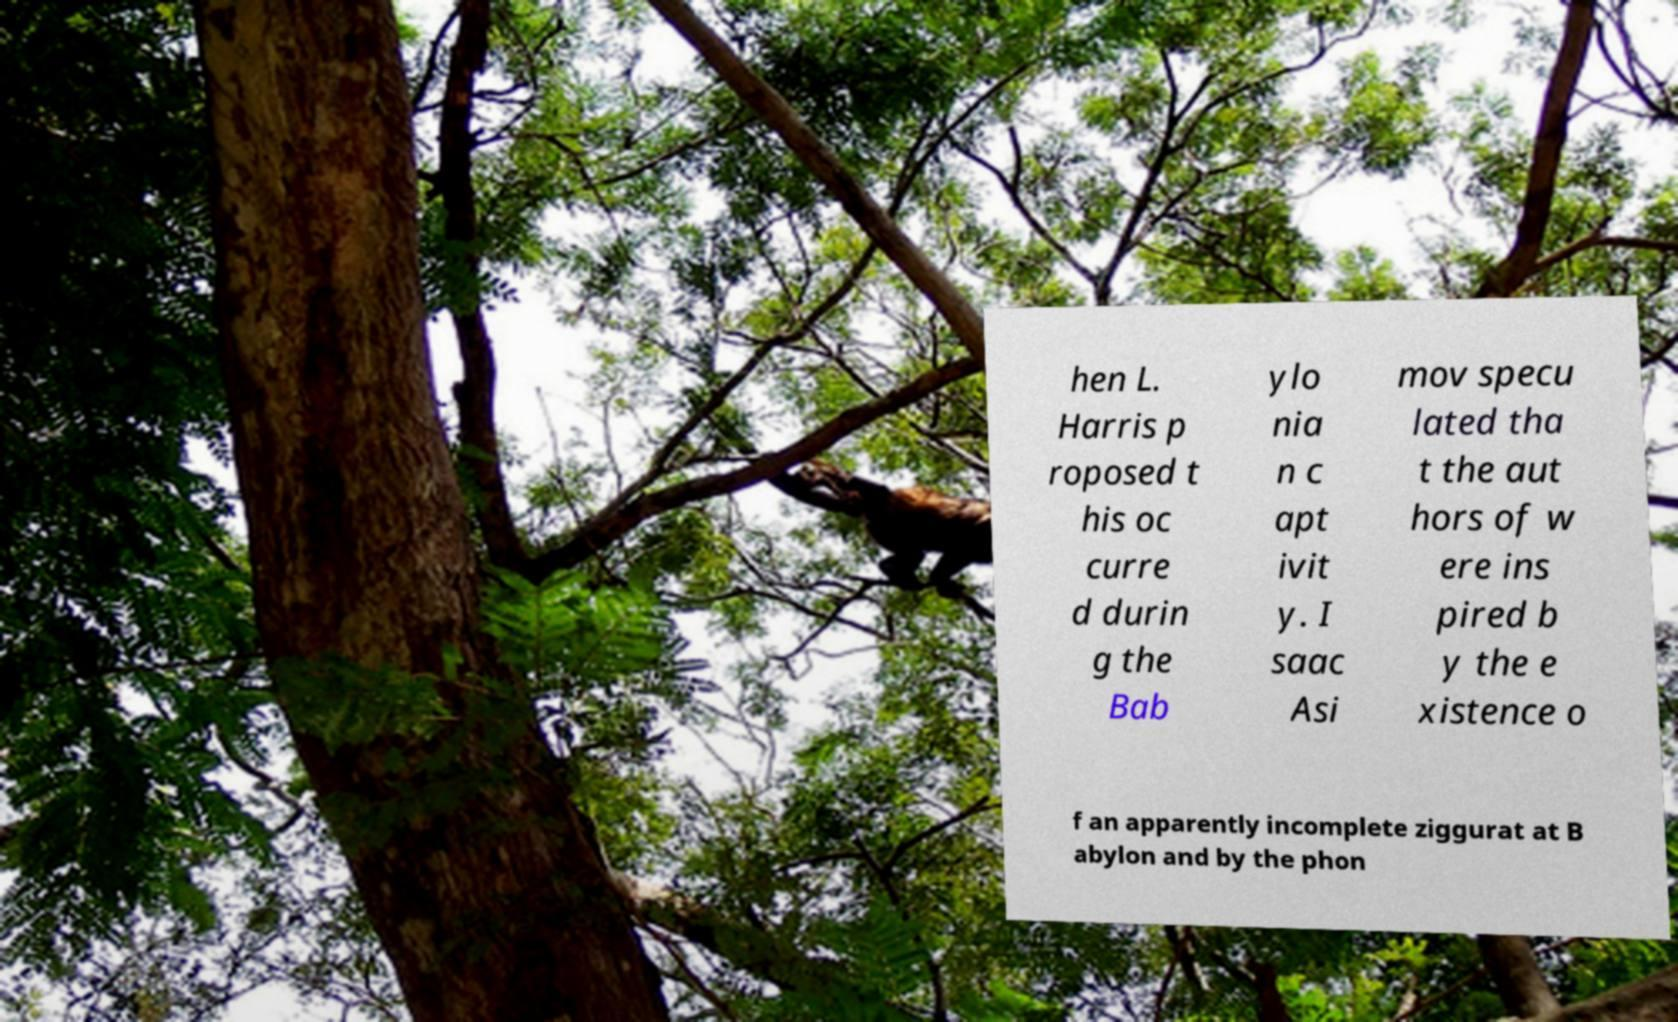Can you read and provide the text displayed in the image?This photo seems to have some interesting text. Can you extract and type it out for me? hen L. Harris p roposed t his oc curre d durin g the Bab ylo nia n c apt ivit y. I saac Asi mov specu lated tha t the aut hors of w ere ins pired b y the e xistence o f an apparently incomplete ziggurat at B abylon and by the phon 